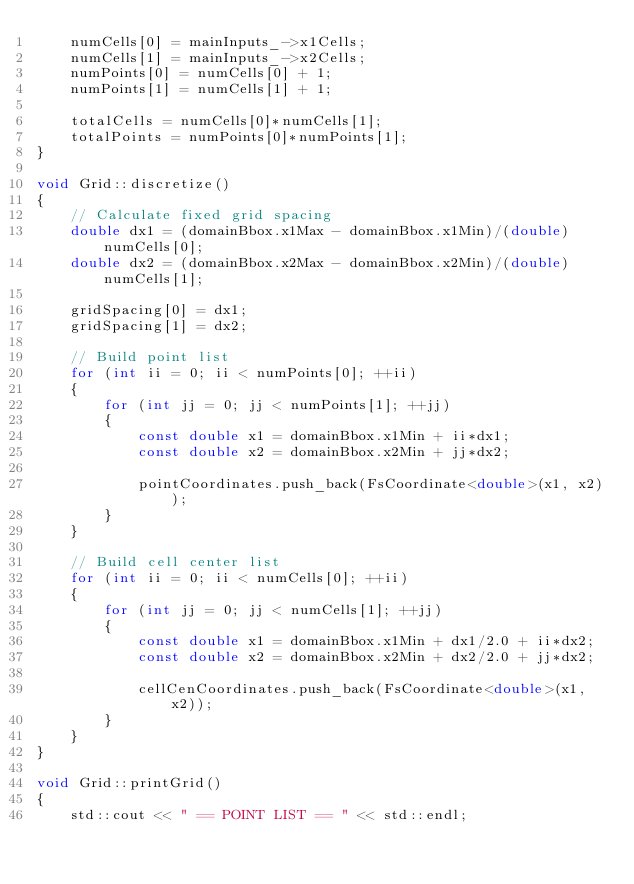Convert code to text. <code><loc_0><loc_0><loc_500><loc_500><_C++_>    numCells[0] = mainInputs_->x1Cells;
    numCells[1] = mainInputs_->x2Cells;
    numPoints[0] = numCells[0] + 1;
    numPoints[1] = numCells[1] + 1;
    
    totalCells = numCells[0]*numCells[1];
    totalPoints = numPoints[0]*numPoints[1];
}

void Grid::discretize()
{
    // Calculate fixed grid spacing
    double dx1 = (domainBbox.x1Max - domainBbox.x1Min)/(double)numCells[0];
    double dx2 = (domainBbox.x2Max - domainBbox.x2Min)/(double)numCells[1];
    
    gridSpacing[0] = dx1;
    gridSpacing[1] = dx2;
    
    // Build point list
    for (int ii = 0; ii < numPoints[0]; ++ii)
    {
        for (int jj = 0; jj < numPoints[1]; ++jj)
        {
            const double x1 = domainBbox.x1Min + ii*dx1;
            const double x2 = domainBbox.x2Min + jj*dx2;
            
            pointCoordinates.push_back(FsCoordinate<double>(x1, x2));
        }
    }
    
    // Build cell center list
    for (int ii = 0; ii < numCells[0]; ++ii)
    {
        for (int jj = 0; jj < numCells[1]; ++jj)
        {
            const double x1 = domainBbox.x1Min + dx1/2.0 + ii*dx2;
            const double x2 = domainBbox.x2Min + dx2/2.0 + jj*dx2;
            
            cellCenCoordinates.push_back(FsCoordinate<double>(x1, x2));
        }
    }
}

void Grid::printGrid()
{
    std::cout << " == POINT LIST == " << std::endl;</code> 